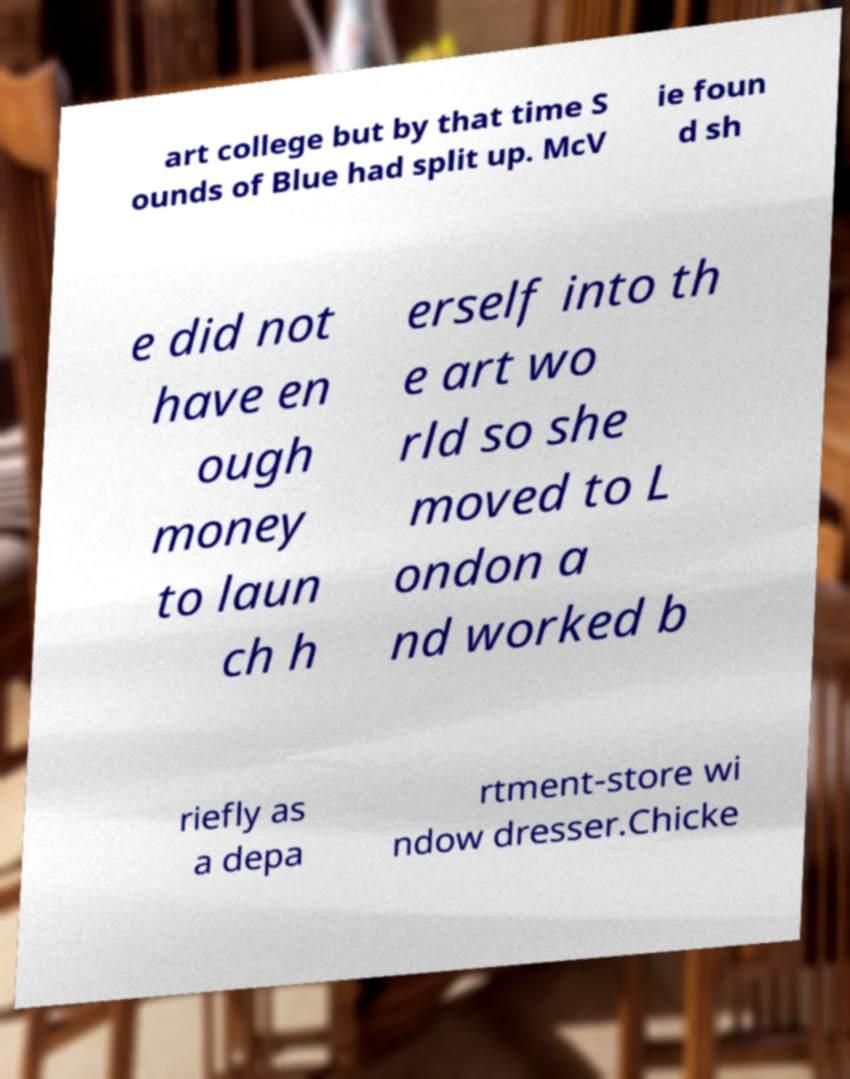Can you read and provide the text displayed in the image?This photo seems to have some interesting text. Can you extract and type it out for me? art college but by that time S ounds of Blue had split up. McV ie foun d sh e did not have en ough money to laun ch h erself into th e art wo rld so she moved to L ondon a nd worked b riefly as a depa rtment-store wi ndow dresser.Chicke 